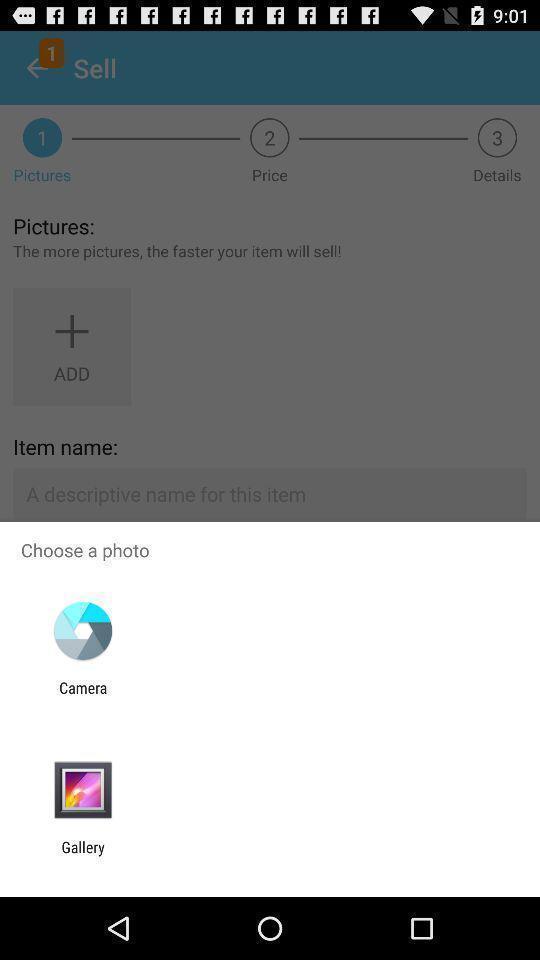Describe the key features of this screenshot. Popup showing different apps to choose. 